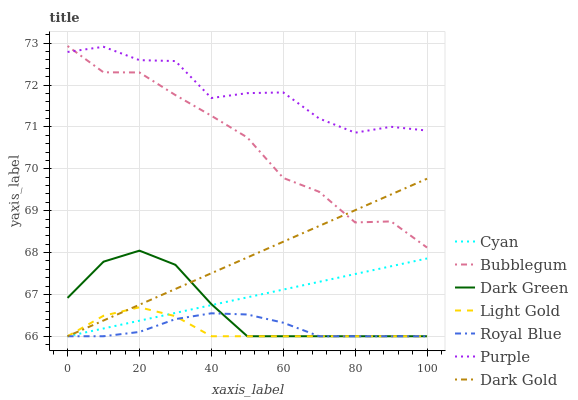Does Light Gold have the minimum area under the curve?
Answer yes or no. Yes. Does Purple have the maximum area under the curve?
Answer yes or no. Yes. Does Bubblegum have the minimum area under the curve?
Answer yes or no. No. Does Bubblegum have the maximum area under the curve?
Answer yes or no. No. Is Dark Gold the smoothest?
Answer yes or no. Yes. Is Purple the roughest?
Answer yes or no. Yes. Is Bubblegum the smoothest?
Answer yes or no. No. Is Bubblegum the roughest?
Answer yes or no. No. Does Dark Gold have the lowest value?
Answer yes or no. Yes. Does Bubblegum have the lowest value?
Answer yes or no. No. Does Bubblegum have the highest value?
Answer yes or no. Yes. Does Purple have the highest value?
Answer yes or no. No. Is Dark Green less than Bubblegum?
Answer yes or no. Yes. Is Bubblegum greater than Royal Blue?
Answer yes or no. Yes. Does Cyan intersect Royal Blue?
Answer yes or no. Yes. Is Cyan less than Royal Blue?
Answer yes or no. No. Is Cyan greater than Royal Blue?
Answer yes or no. No. Does Dark Green intersect Bubblegum?
Answer yes or no. No. 